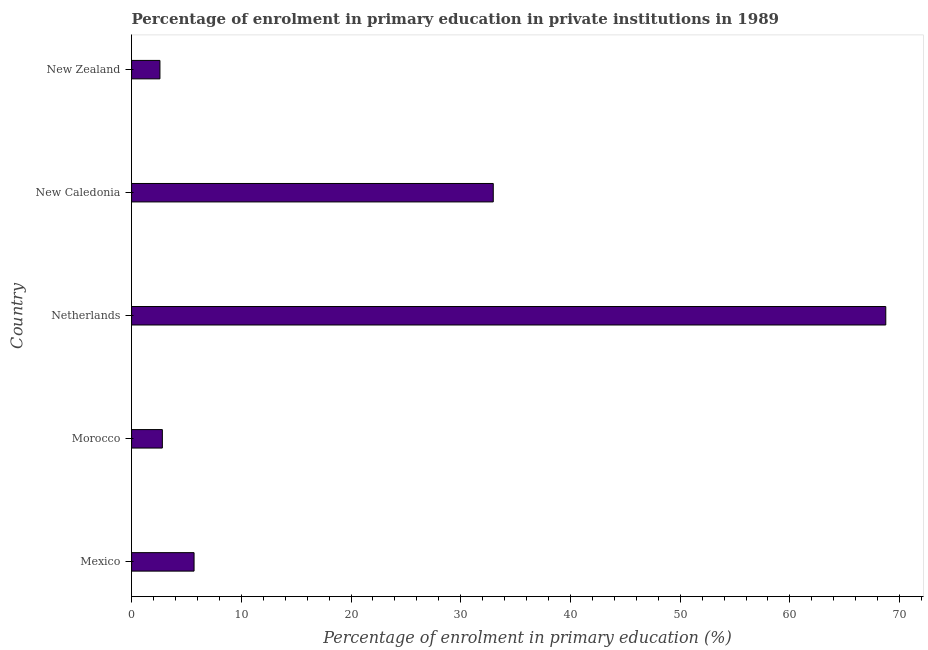Does the graph contain grids?
Provide a succinct answer. No. What is the title of the graph?
Your answer should be compact. Percentage of enrolment in primary education in private institutions in 1989. What is the label or title of the X-axis?
Make the answer very short. Percentage of enrolment in primary education (%). What is the label or title of the Y-axis?
Ensure brevity in your answer.  Country. What is the enrolment percentage in primary education in Netherlands?
Provide a succinct answer. 68.74. Across all countries, what is the maximum enrolment percentage in primary education?
Make the answer very short. 68.74. Across all countries, what is the minimum enrolment percentage in primary education?
Your answer should be very brief. 2.58. In which country was the enrolment percentage in primary education minimum?
Offer a terse response. New Zealand. What is the sum of the enrolment percentage in primary education?
Keep it short and to the point. 112.79. What is the difference between the enrolment percentage in primary education in Mexico and New Zealand?
Ensure brevity in your answer.  3.11. What is the average enrolment percentage in primary education per country?
Keep it short and to the point. 22.56. What is the median enrolment percentage in primary education?
Keep it short and to the point. 5.7. What is the ratio of the enrolment percentage in primary education in Morocco to that in New Zealand?
Offer a terse response. 1.09. Is the difference between the enrolment percentage in primary education in Netherlands and New Caledonia greater than the difference between any two countries?
Your answer should be compact. No. What is the difference between the highest and the second highest enrolment percentage in primary education?
Give a very brief answer. 35.77. What is the difference between the highest and the lowest enrolment percentage in primary education?
Offer a terse response. 66.15. In how many countries, is the enrolment percentage in primary education greater than the average enrolment percentage in primary education taken over all countries?
Offer a very short reply. 2. How many bars are there?
Give a very brief answer. 5. Are the values on the major ticks of X-axis written in scientific E-notation?
Keep it short and to the point. No. What is the Percentage of enrolment in primary education (%) of Mexico?
Provide a succinct answer. 5.7. What is the Percentage of enrolment in primary education (%) in Morocco?
Your response must be concise. 2.8. What is the Percentage of enrolment in primary education (%) of Netherlands?
Ensure brevity in your answer.  68.74. What is the Percentage of enrolment in primary education (%) of New Caledonia?
Your answer should be compact. 32.96. What is the Percentage of enrolment in primary education (%) of New Zealand?
Offer a terse response. 2.58. What is the difference between the Percentage of enrolment in primary education (%) in Mexico and Morocco?
Your response must be concise. 2.89. What is the difference between the Percentage of enrolment in primary education (%) in Mexico and Netherlands?
Your answer should be very brief. -63.04. What is the difference between the Percentage of enrolment in primary education (%) in Mexico and New Caledonia?
Keep it short and to the point. -27.27. What is the difference between the Percentage of enrolment in primary education (%) in Mexico and New Zealand?
Your response must be concise. 3.11. What is the difference between the Percentage of enrolment in primary education (%) in Morocco and Netherlands?
Your response must be concise. -65.93. What is the difference between the Percentage of enrolment in primary education (%) in Morocco and New Caledonia?
Make the answer very short. -30.16. What is the difference between the Percentage of enrolment in primary education (%) in Morocco and New Zealand?
Your answer should be compact. 0.22. What is the difference between the Percentage of enrolment in primary education (%) in Netherlands and New Caledonia?
Keep it short and to the point. 35.77. What is the difference between the Percentage of enrolment in primary education (%) in Netherlands and New Zealand?
Ensure brevity in your answer.  66.15. What is the difference between the Percentage of enrolment in primary education (%) in New Caledonia and New Zealand?
Make the answer very short. 30.38. What is the ratio of the Percentage of enrolment in primary education (%) in Mexico to that in Morocco?
Your response must be concise. 2.03. What is the ratio of the Percentage of enrolment in primary education (%) in Mexico to that in Netherlands?
Keep it short and to the point. 0.08. What is the ratio of the Percentage of enrolment in primary education (%) in Mexico to that in New Caledonia?
Ensure brevity in your answer.  0.17. What is the ratio of the Percentage of enrolment in primary education (%) in Mexico to that in New Zealand?
Your answer should be compact. 2.2. What is the ratio of the Percentage of enrolment in primary education (%) in Morocco to that in Netherlands?
Ensure brevity in your answer.  0.04. What is the ratio of the Percentage of enrolment in primary education (%) in Morocco to that in New Caledonia?
Your answer should be very brief. 0.09. What is the ratio of the Percentage of enrolment in primary education (%) in Morocco to that in New Zealand?
Give a very brief answer. 1.09. What is the ratio of the Percentage of enrolment in primary education (%) in Netherlands to that in New Caledonia?
Your answer should be compact. 2.08. What is the ratio of the Percentage of enrolment in primary education (%) in Netherlands to that in New Zealand?
Your response must be concise. 26.6. What is the ratio of the Percentage of enrolment in primary education (%) in New Caledonia to that in New Zealand?
Keep it short and to the point. 12.76. 